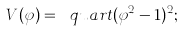Convert formula to latex. <formula><loc_0><loc_0><loc_500><loc_500>V ( \varphi ) = \ q u a r t ( \varphi ^ { 2 } - 1 ) ^ { 2 } ;</formula> 